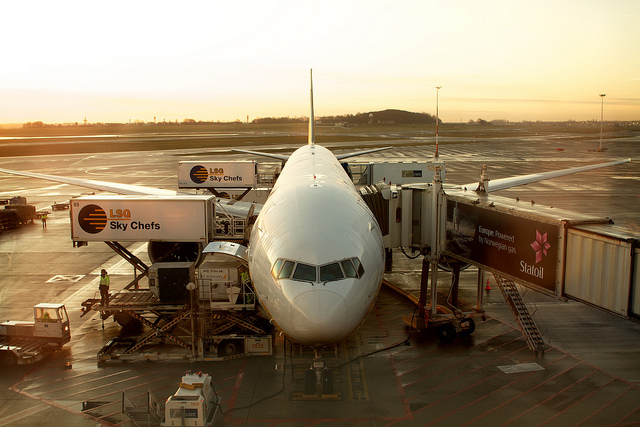Please identify all text content in this image. Sky Chola LSQ Sky Chefs Statoil 